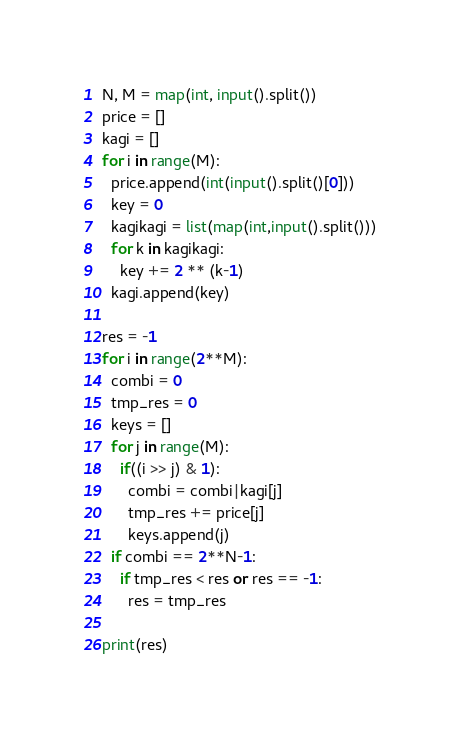Convert code to text. <code><loc_0><loc_0><loc_500><loc_500><_Python_>N, M = map(int, input().split())
price = []
kagi = []
for i in range(M):
  price.append(int(input().split()[0]))
  key = 0
  kagikagi = list(map(int,input().split()))
  for k in kagikagi:
    key += 2 ** (k-1)
  kagi.append(key)

res = -1
for i in range(2**M):
  combi = 0
  tmp_res = 0
  keys = []
  for j in range(M):
    if((i >> j) & 1):
      combi = combi|kagi[j]
      tmp_res += price[j]
      keys.append(j)
  if combi == 2**N-1:
    if tmp_res < res or res == -1:
      res = tmp_res
      
print(res)</code> 